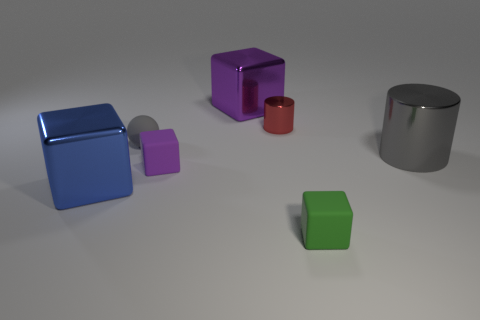Subtract 1 blocks. How many blocks are left? 3 Add 1 tiny brown rubber spheres. How many objects exist? 8 Subtract all blocks. How many objects are left? 3 Add 2 red shiny things. How many red shiny things are left? 3 Add 5 big things. How many big things exist? 8 Subtract 0 purple cylinders. How many objects are left? 7 Subtract all small red metallic cylinders. Subtract all tiny purple matte things. How many objects are left? 5 